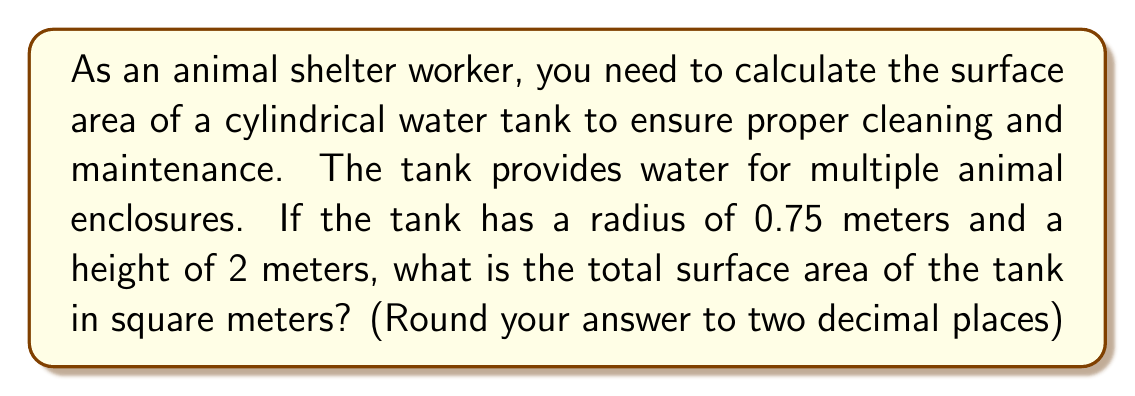Help me with this question. To calculate the surface area of a cylindrical tank, we need to consider three parts:
1. The circular top
2. The circular bottom
3. The curved lateral surface

Let's break it down step-by-step:

1. Area of the circular top and bottom:
   The area of a circle is given by the formula $A = \pi r^2$
   $$A_{circle} = \pi (0.75)^2 = 1.7671 \text{ m}^2$$
   We have two circular surfaces (top and bottom), so:
   $$A_{circles} = 2 \times 1.7671 = 3.5342 \text{ m}^2$$

2. Area of the curved lateral surface:
   The lateral surface area of a cylinder is given by the formula $A = 2\pi rh$
   where $r$ is the radius and $h$ is the height.
   $$A_{lateral} = 2\pi (0.75)(2) = 9.4248 \text{ m}^2$$

3. Total surface area:
   Sum up the areas of the circular surfaces and the lateral surface
   $$A_{total} = A_{circles} + A_{lateral}$$
   $$A_{total} = 3.5342 + 9.4248 = 12.9590 \text{ m}^2$$

Rounding to two decimal places, we get 12.96 m².

[asy]
import geometry;

size(200);
real r = 0.75;
real h = 2;
pair O = (0,0);
pair A = (r,0);
pair B = (r,h);
pair C = (-r,h);
pair D = (-r,0);

draw(circle(O,r));
draw(circle((0,h),r));
draw(A--B);
draw(C--D);
draw((r,0)--(r,h),dashed);
draw((-r,0)--(-r,h),dashed);

label("r",(r/2,0),S);
label("h",(r,h/2),E);

</asy>
Answer: 12.96 m² 